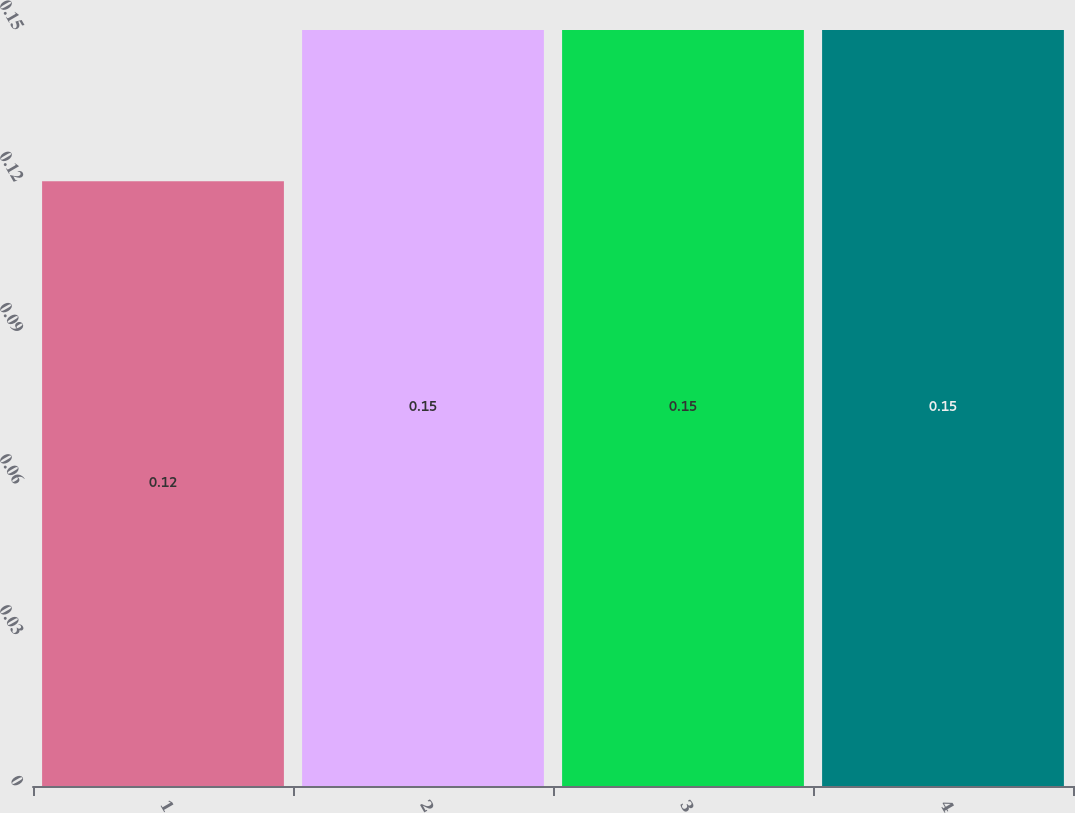<chart> <loc_0><loc_0><loc_500><loc_500><bar_chart><fcel>1<fcel>2<fcel>3<fcel>4<nl><fcel>0.12<fcel>0.15<fcel>0.15<fcel>0.15<nl></chart> 